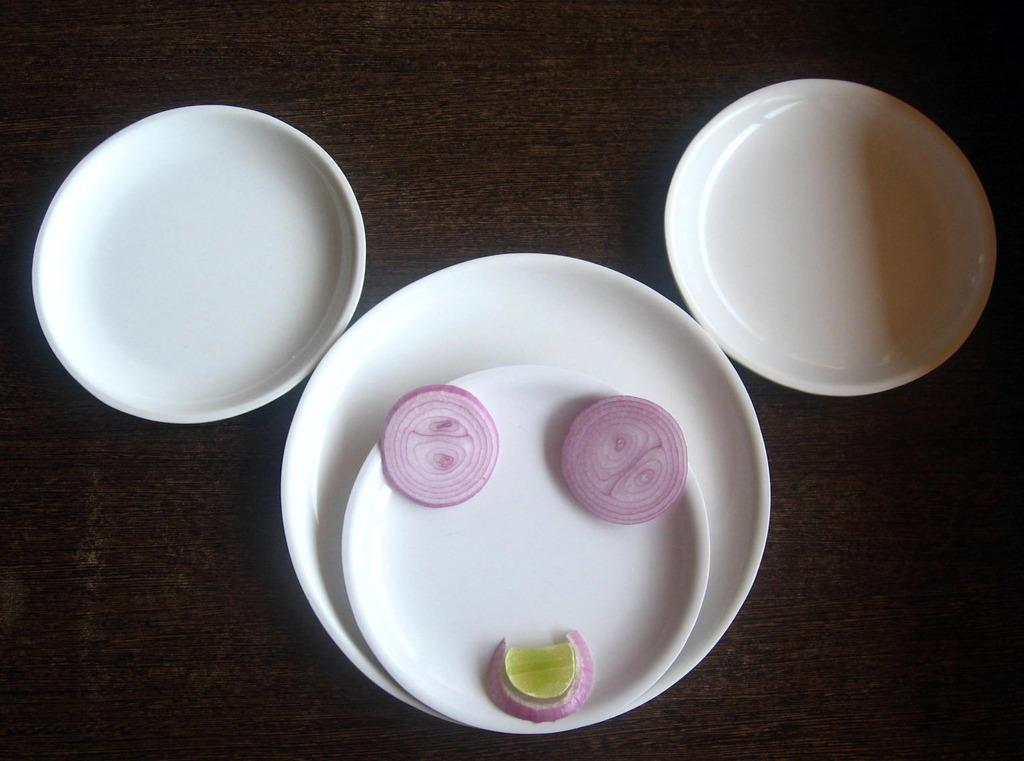How many plates are visible in the image? There are four plates in the image. What is on one of the plates? One of the plates contains chopped onions and a lemon. What is the color of the table on which the plates are placed? The plates are placed on a brown table. What type of needle is used to cut the tomatoes in the image? There are no tomatoes or needles present in the image. 